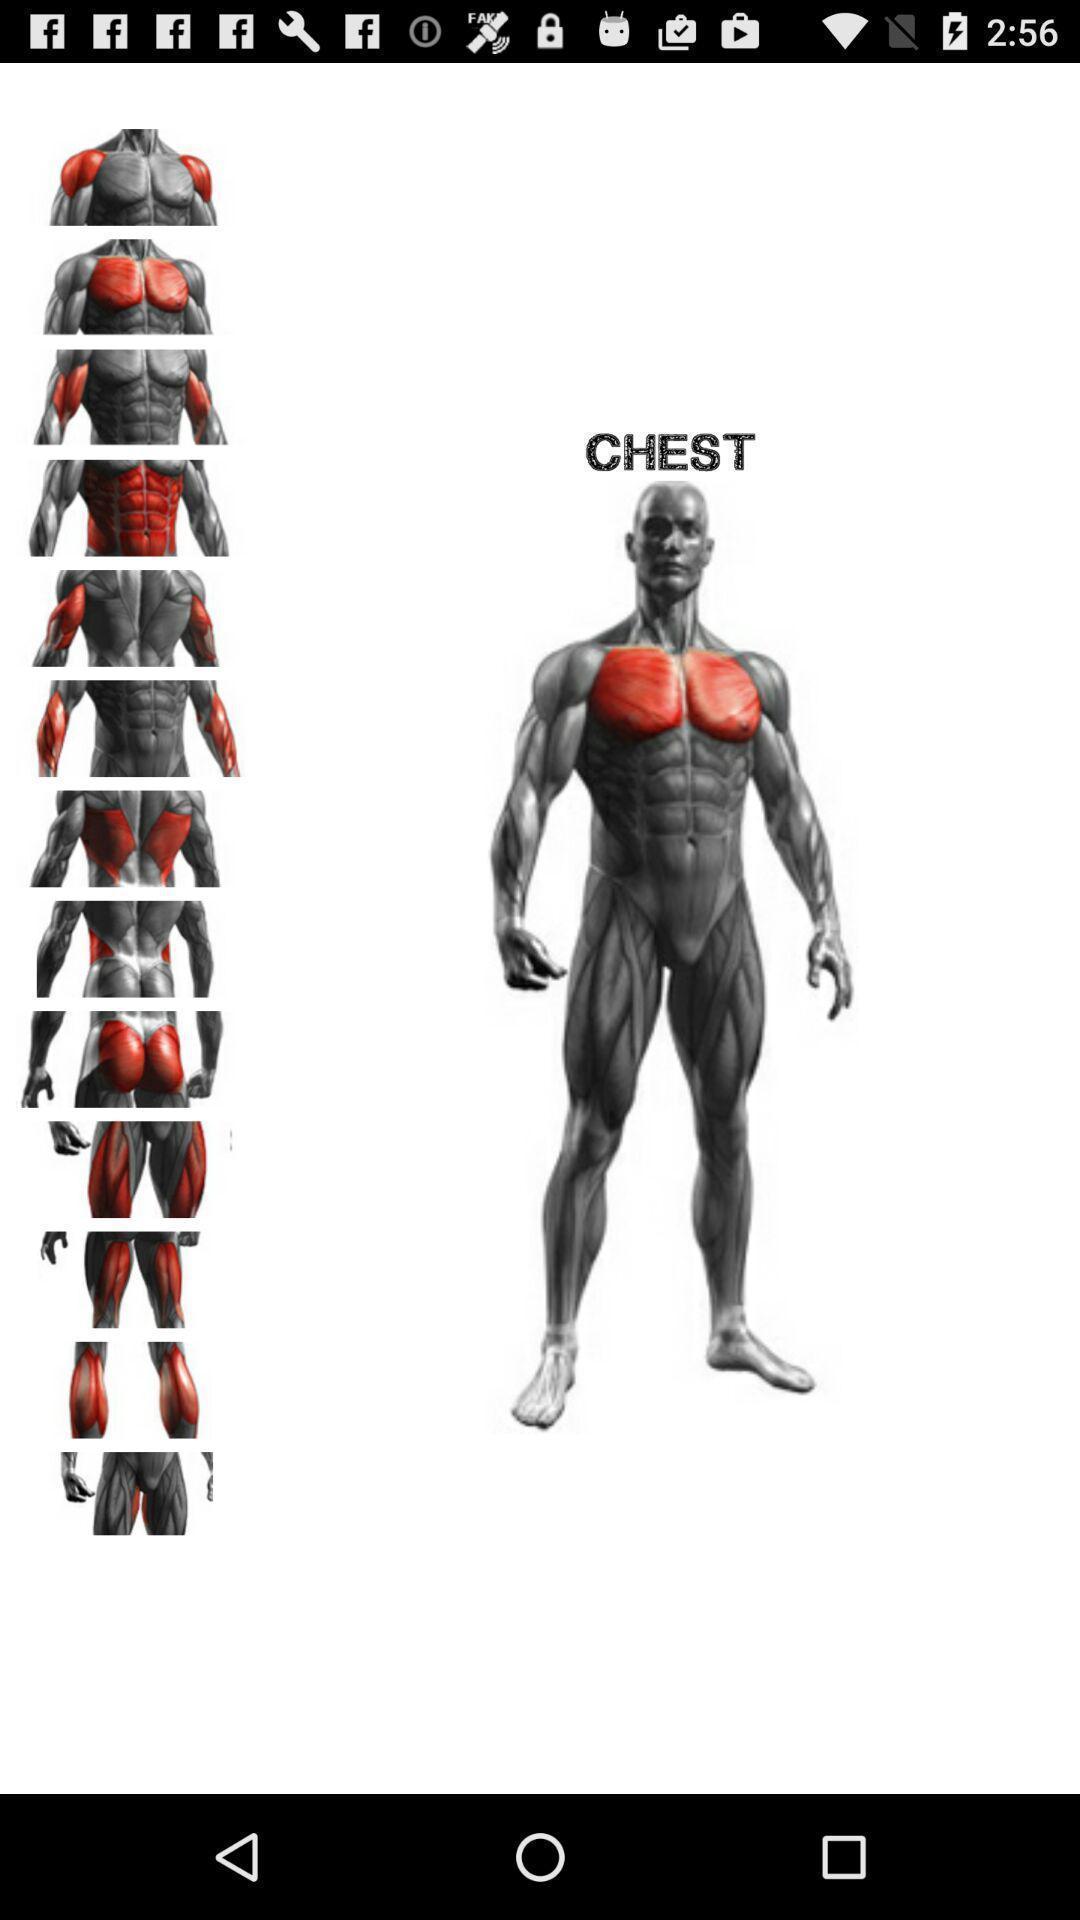Give me a narrative description of this picture. Workout page of a gym training app. 